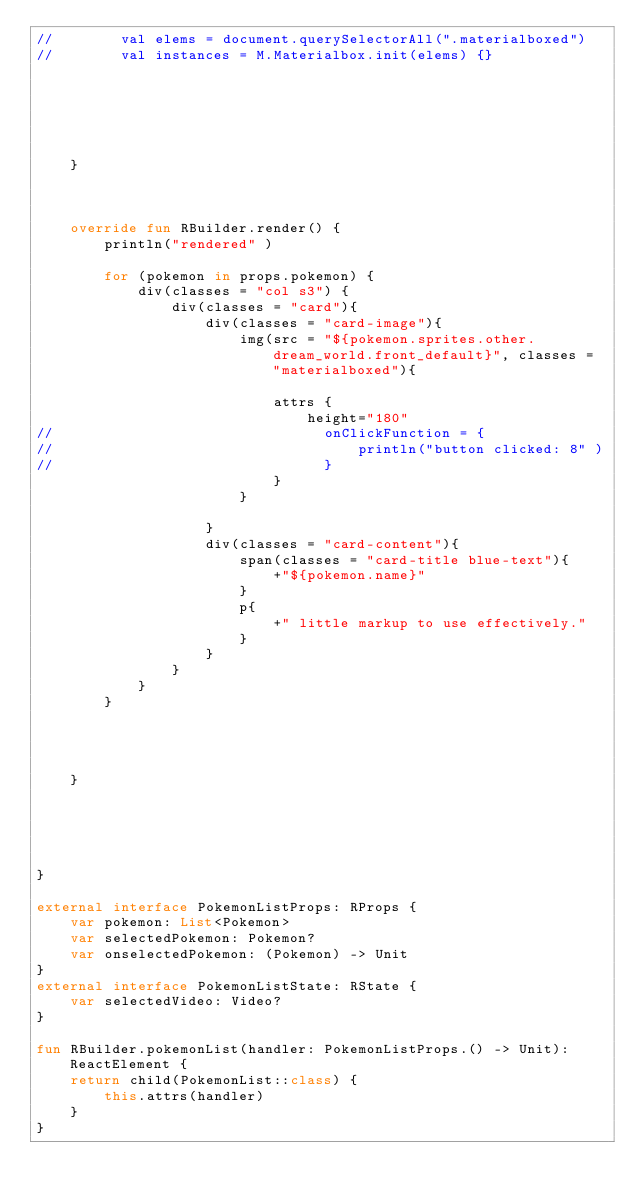Convert code to text. <code><loc_0><loc_0><loc_500><loc_500><_Kotlin_>//        val elems = document.querySelectorAll(".materialboxed")
//        val instances = M.Materialbox.init(elems) {}






    }



    override fun RBuilder.render() {
        println("rendered" )

        for (pokemon in props.pokemon) {
            div(classes = "col s3") {
                div(classes = "card"){
                    div(classes = "card-image"){
                        img(src = "${pokemon.sprites.other.dream_world.front_default}", classes = "materialboxed"){

                            attrs {
                                height="180"
//                                onClickFunction = {
//                                    println("button clicked: 8" )
//                                }
                            }
                        }

                    }
                    div(classes = "card-content"){
                        span(classes = "card-title blue-text"){
                            +"${pokemon.name}"
                        }
                        p{
                            +" little markup to use effectively."
                        }
                    }
                }
            }
        }




    }





}

external interface PokemonListProps: RProps {
    var pokemon: List<Pokemon>
    var selectedPokemon: Pokemon?
    var onselectedPokemon: (Pokemon) -> Unit
}
external interface PokemonListState: RState {
    var selectedVideo: Video?
}

fun RBuilder.pokemonList(handler: PokemonListProps.() -> Unit): ReactElement {
    return child(PokemonList::class) {
        this.attrs(handler)
    }
}</code> 